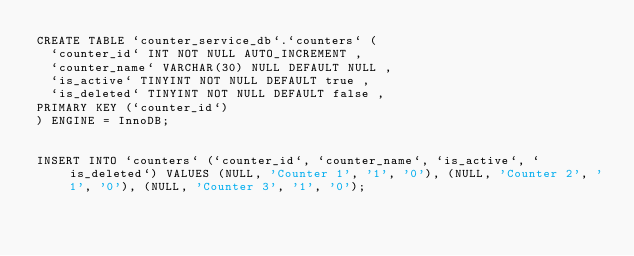Convert code to text. <code><loc_0><loc_0><loc_500><loc_500><_SQL_>CREATE TABLE `counter_service_db`.`counters` ( 
	`counter_id` INT NOT NULL AUTO_INCREMENT , 
	`counter_name` VARCHAR(30) NULL DEFAULT NULL , 
	`is_active` TINYINT NOT NULL DEFAULT true , 
	`is_deleted` TINYINT NOT NULL DEFAULT false , 
PRIMARY KEY (`counter_id`)
) ENGINE = InnoDB;


INSERT INTO `counters` (`counter_id`, `counter_name`, `is_active`, `is_deleted`) VALUES (NULL, 'Counter 1', '1', '0'), (NULL, 'Counter 2', '1', '0'), (NULL, 'Counter 3', '1', '0');

</code> 